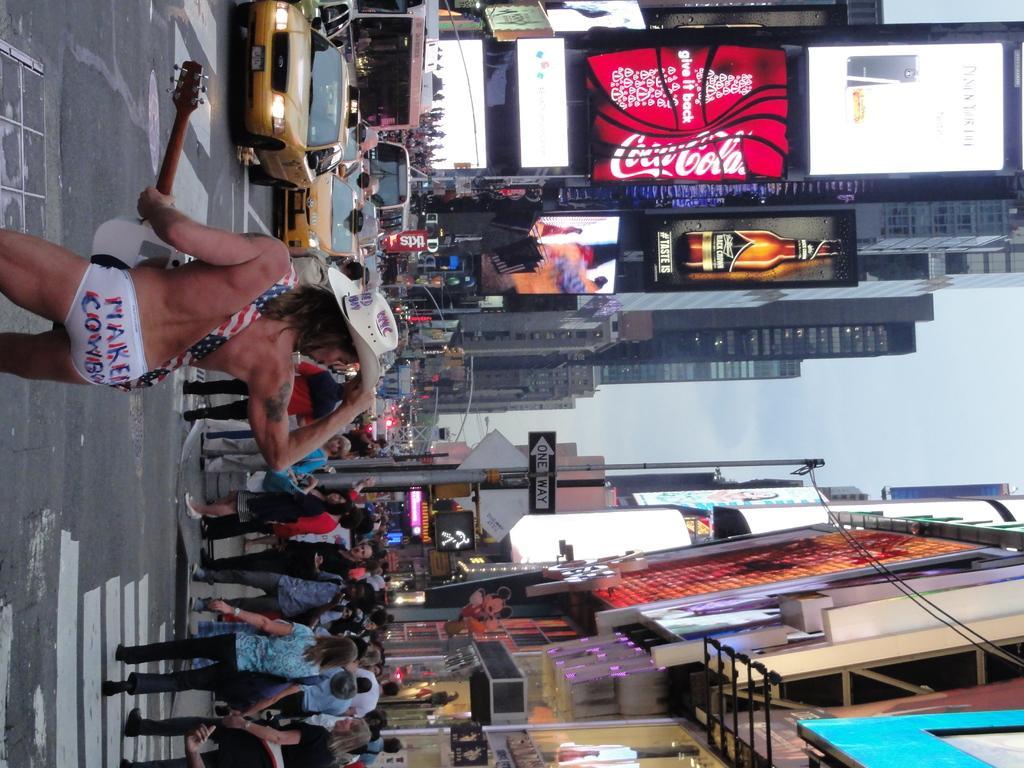Can you describe this image briefly? In this image we can see a group of people standing on the road. One person wearing a cap is holding a guitar in his hands. In the background, we can see a group of cars parked on the road, a group of buildings and sky. 